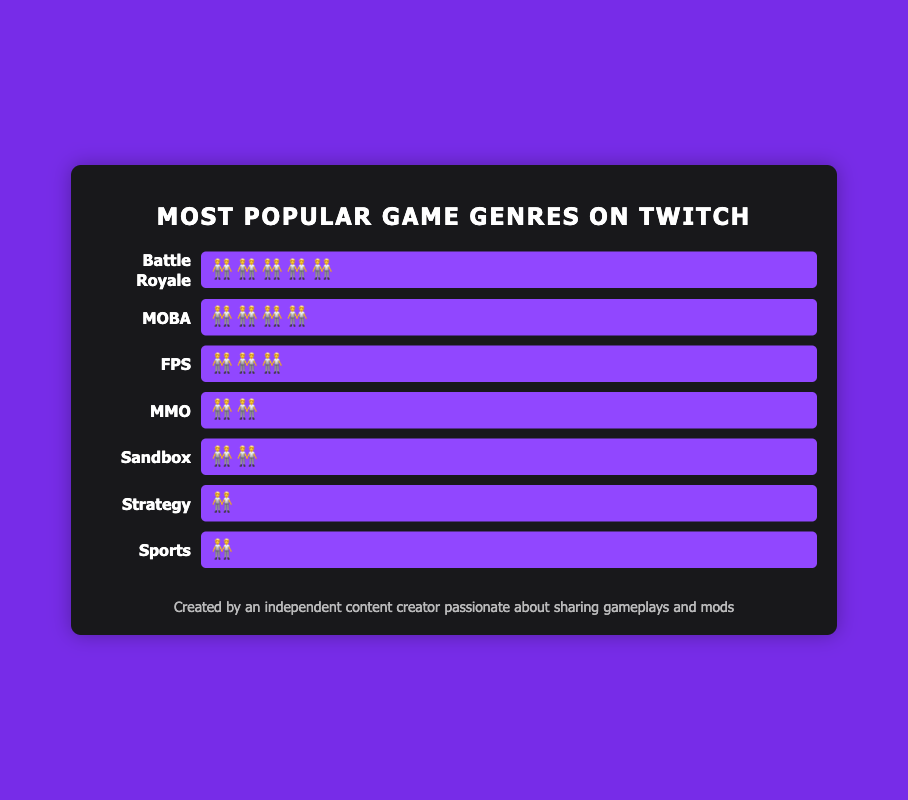Which game genre has the highest viewer count? The game with the longest series of the "🧑‍🤝‍🧑" emoji represents the genre with the highest viewer count. The genre "Battle Royale" has the most "🧑‍🤝‍🧑" emojis.
Answer: Battle Royale Which game genres have the same viewer count? The genres with the same number of "🧑‍🤝‍🧑" emojis have equal viewer counts. Both "Strategy" and "Sports" genres have a count of one "🧑‍🤝‍🧑" emoji.
Answer: Strategy and Sports How many more viewers does Battle Royale have compared to FPS? Count the "🧑‍🤝‍🧑" emojis for each genre and find the difference. Battle Royale has five emojis, and FPS has three emojis. So, \(5 - 3 = 2\). Battle Royale has two more "🧑‍🤝‍🧑" emojis.
Answer: 2 What is the total viewer count for MMO and Sandbox combined? Adding the number of "🧑‍🤝‍🧑" emojis for both genres: MMO has two emojis and Sandbox also has two emojis. \(2 + 2 = 4\).
Answer: 4 Are there more viewers for MOBA or for FPS? Compare the count of "🧑‍🤝‍🧑" emojis for each genre. MOBA has four emojis, while FPS has three emojis.
Answer: MOBA What is the average number of viewers for all the genres combined? Add up all the "🧑‍🤝‍🧑" emojis for all genres and divide by the number of genres, which is seven: \(5 + 4 + 3 + 2 + 2 + 1 + 1 = 18\). The average is \(18 / 7 \approx 2.57\).
Answer: ~2.57 What is the least popular game genre based on viewer count? The genre with the fewest "🧑‍🤝‍🧑" emoji represents the least popular genre. Both "Strategy" and "Sports" have the smallest count of one "🧑‍🤝‍🧑" emoji each.
Answer: Strategy and Sports By how much does the viewer count for MOBA exceed that for MMO? Count the "🧑‍🤝‍🧑" emojis for both and find the difference. MOBA has four, MMO has two. \(4 - 2 = 2\).
Answer: 2 Which game genres have fewer viewers than FPS? Identify genres with fewer "🧑‍🤝‍🧑" emojis compared to FPS (which has three). MMO, Sandbox, Strategy, and Sports have two or fewer "🧑‍🤝‍🧑" emojis.
Answer: MMO, Sandbox, Strategy, and Sports 